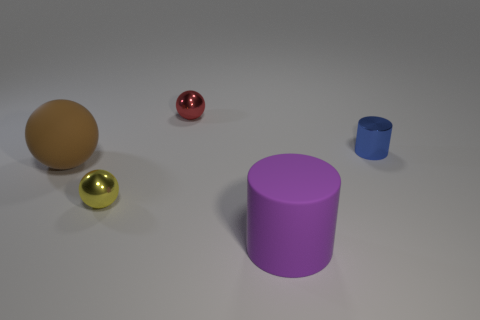Can you infer anything about the lighting of the scene? The scene is illuminated by a diffuse light source, as evidenced by the soft shadows cast by the objects, suggesting an overcast day or a soft-box light in a studio setting. The absence of harsh shadows indicates that the light is not direct. What can the reflections on the objects tell us about the environment? The reflections, especially visible on the shiny spheres, indicate a bright and diffused light source. The lack of distinct reflections suggests there are no immediate large objects surrounding the scene, which might be indicative of an isolated setup in an open space. 